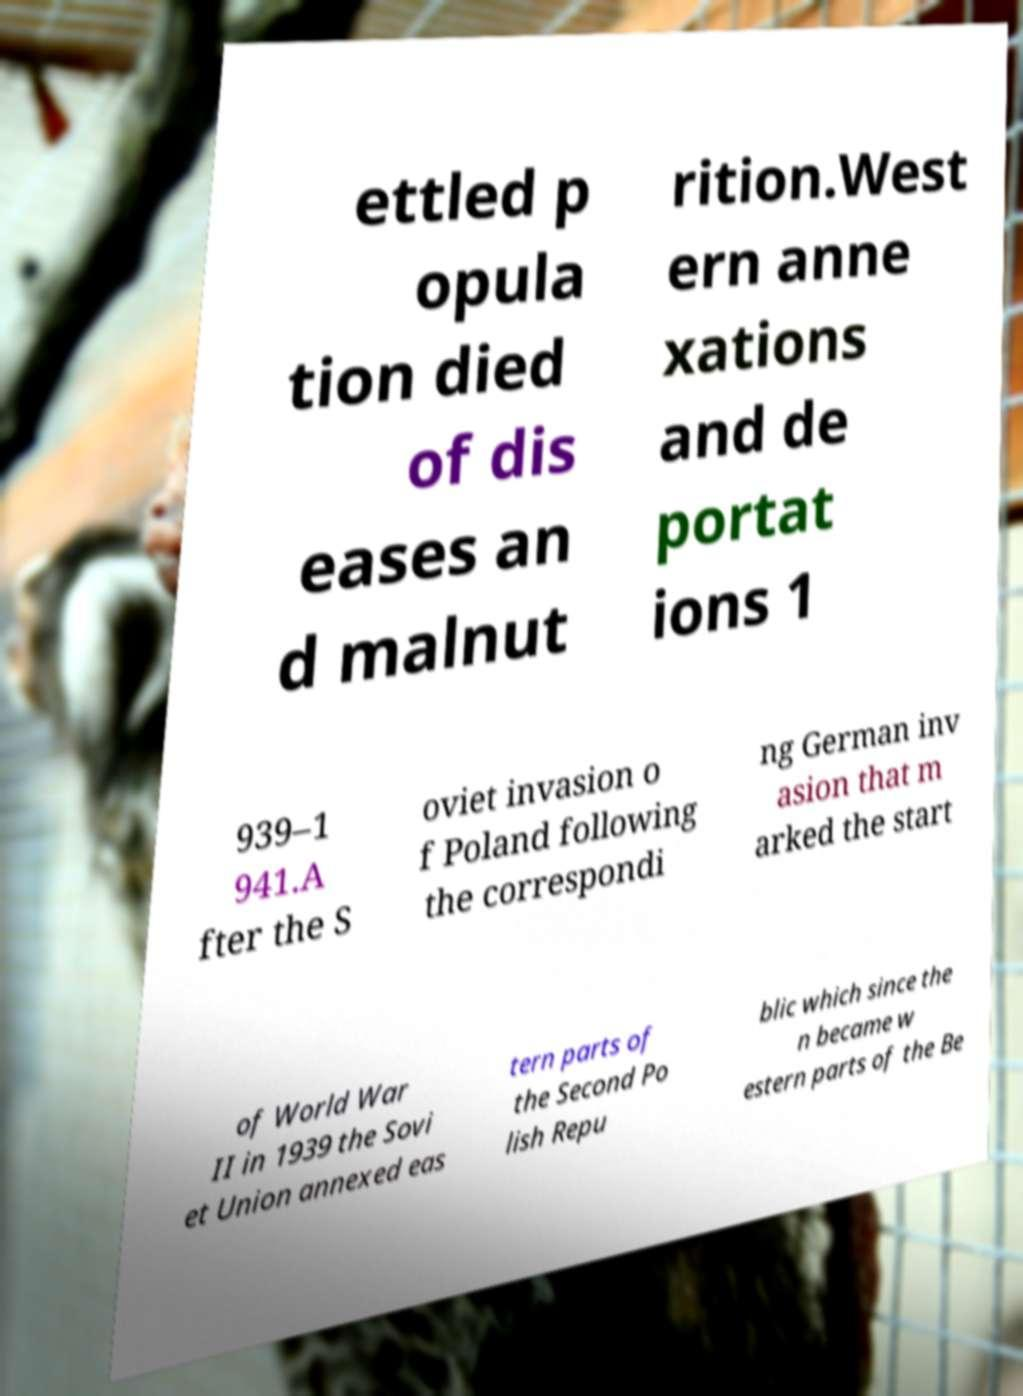Please identify and transcribe the text found in this image. ettled p opula tion died of dis eases an d malnut rition.West ern anne xations and de portat ions 1 939–1 941.A fter the S oviet invasion o f Poland following the correspondi ng German inv asion that m arked the start of World War II in 1939 the Sovi et Union annexed eas tern parts of the Second Po lish Repu blic which since the n became w estern parts of the Be 